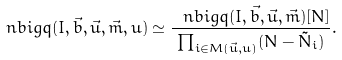<formula> <loc_0><loc_0><loc_500><loc_500>\ n b i g q ( I , \vec { b } , \vec { u } , \vec { m } , u ) \simeq \frac { \ n b i g q ( I , \vec { b } , \vec { u } , \vec { m } ) [ N ] } { \prod _ { i \in M ( \vec { u } , u ) } ( N - \tilde { N } _ { i } ) } .</formula> 